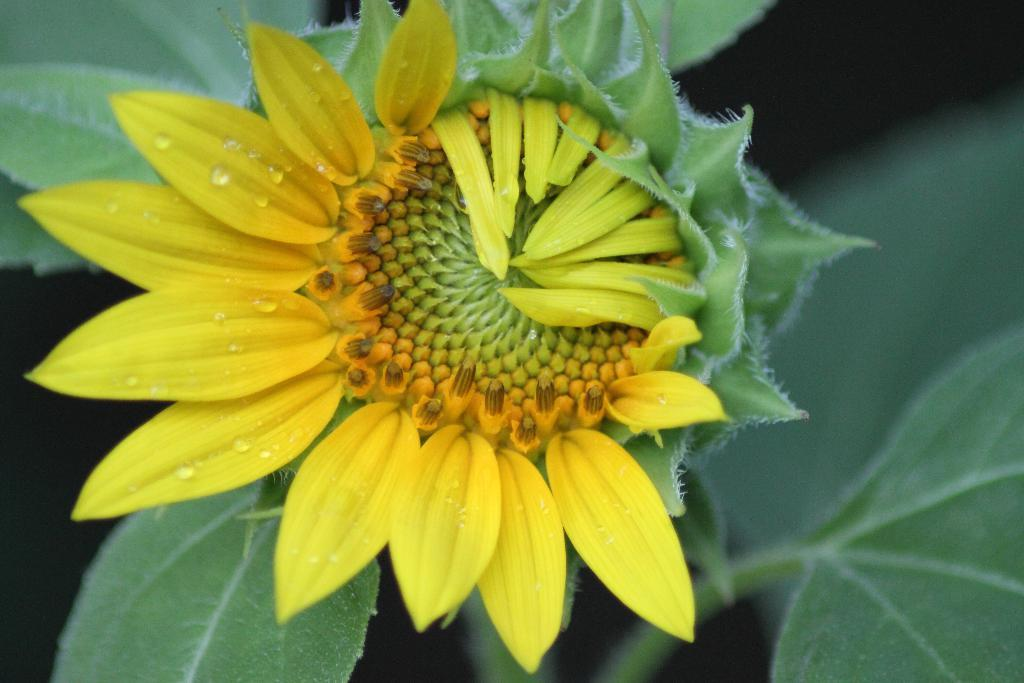What type of plant is in the image? There is a plant in the image. What is the most prominent feature of the plant? The plant has a yellow sunflower on it. What type of celery can be seen growing in the image? There is no celery present in the image; it only features a plant with a yellow sunflower. 